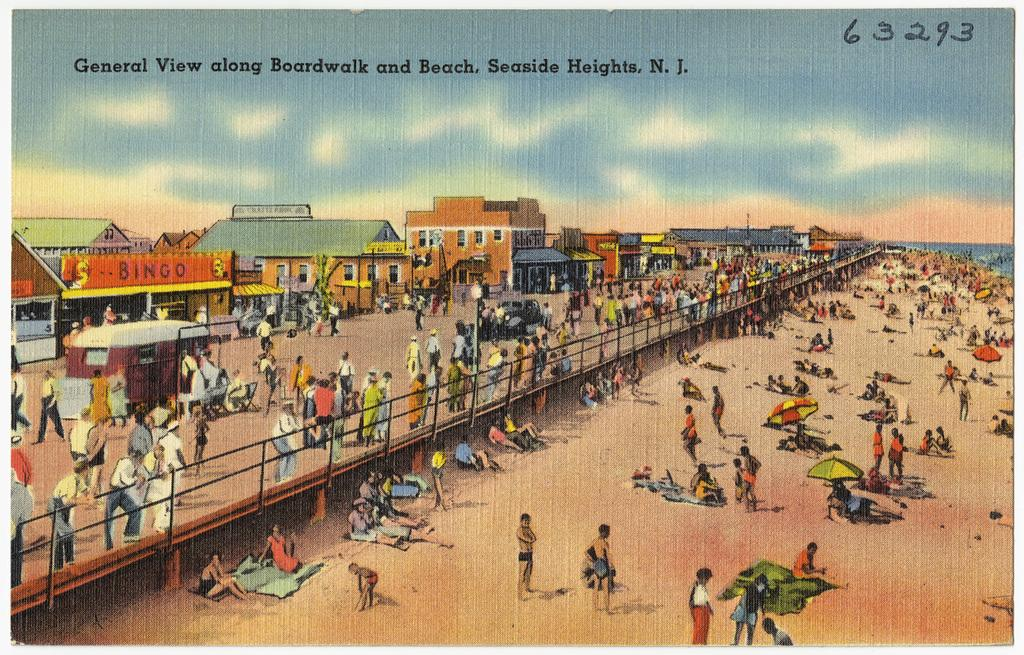<image>
Write a terse but informative summary of the picture. Post card showing people at the beach and the number 63293 on the top. 